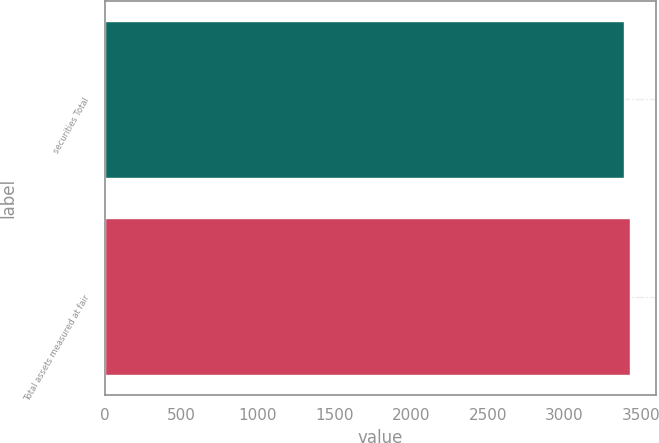Convert chart to OTSL. <chart><loc_0><loc_0><loc_500><loc_500><bar_chart><fcel>securities Total<fcel>Total assets measured at fair<nl><fcel>3388.6<fcel>3425.4<nl></chart> 